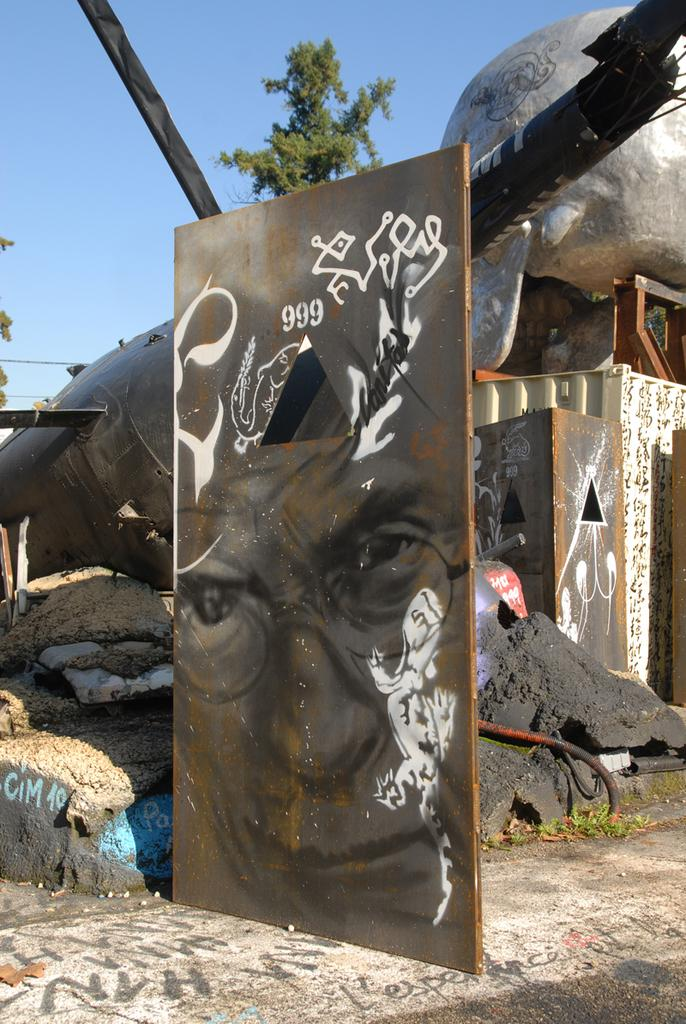What type of structure is visible in the image? There is a building in the image. What material is present in the image? There are stones in the image. What type of artwork is featured in the image? There is a painting in the image. What can be seen in the background of the image? There are trees in the background of the image. What is the condition of the sky in the image? The sky is clear in the image. What religious symbol can be seen in the image? There is no religious symbol present in the image. What type of hate can be observed in the image? There is no hate present in the image. How many toes are visible in the image? There are no toes visible in the image. 